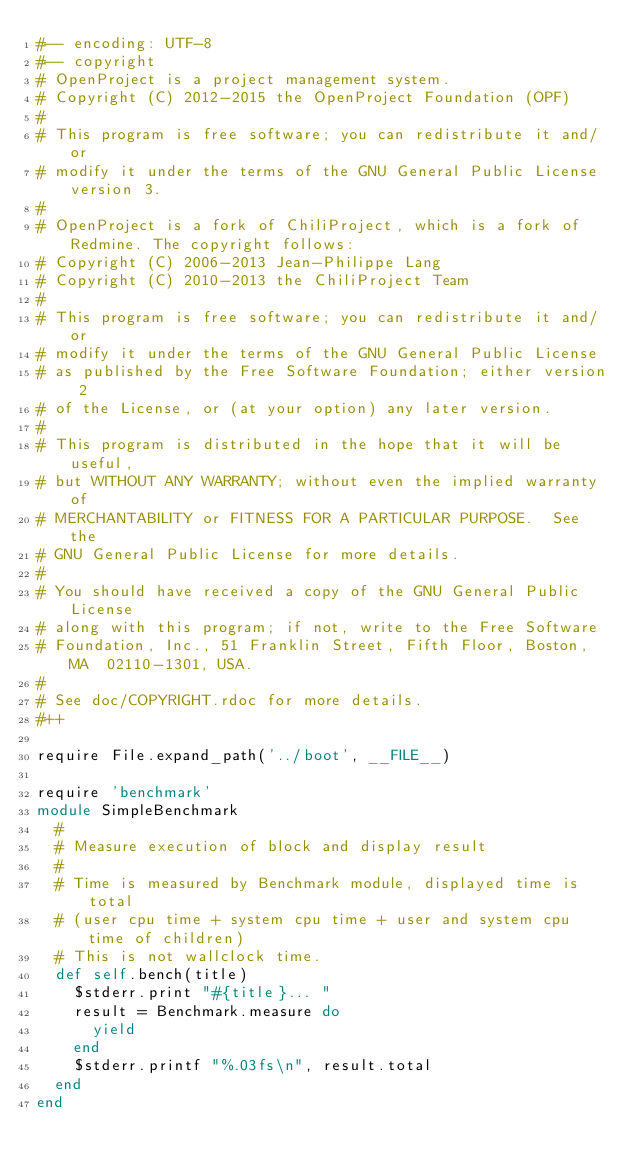Convert code to text. <code><loc_0><loc_0><loc_500><loc_500><_Ruby_>#-- encoding: UTF-8
#-- copyright
# OpenProject is a project management system.
# Copyright (C) 2012-2015 the OpenProject Foundation (OPF)
#
# This program is free software; you can redistribute it and/or
# modify it under the terms of the GNU General Public License version 3.
#
# OpenProject is a fork of ChiliProject, which is a fork of Redmine. The copyright follows:
# Copyright (C) 2006-2013 Jean-Philippe Lang
# Copyright (C) 2010-2013 the ChiliProject Team
#
# This program is free software; you can redistribute it and/or
# modify it under the terms of the GNU General Public License
# as published by the Free Software Foundation; either version 2
# of the License, or (at your option) any later version.
#
# This program is distributed in the hope that it will be useful,
# but WITHOUT ANY WARRANTY; without even the implied warranty of
# MERCHANTABILITY or FITNESS FOR A PARTICULAR PURPOSE.  See the
# GNU General Public License for more details.
#
# You should have received a copy of the GNU General Public License
# along with this program; if not, write to the Free Software
# Foundation, Inc., 51 Franklin Street, Fifth Floor, Boston, MA  02110-1301, USA.
#
# See doc/COPYRIGHT.rdoc for more details.
#++

require File.expand_path('../boot', __FILE__)

require 'benchmark'
module SimpleBenchmark
  #
  # Measure execution of block and display result
  #
  # Time is measured by Benchmark module, displayed time is total
  # (user cpu time + system cpu time + user and system cpu time of children)
  # This is not wallclock time.
  def self.bench(title)
    $stderr.print "#{title}... "
    result = Benchmark.measure do
      yield
    end
    $stderr.printf "%.03fs\n", result.total
  end
end
</code> 